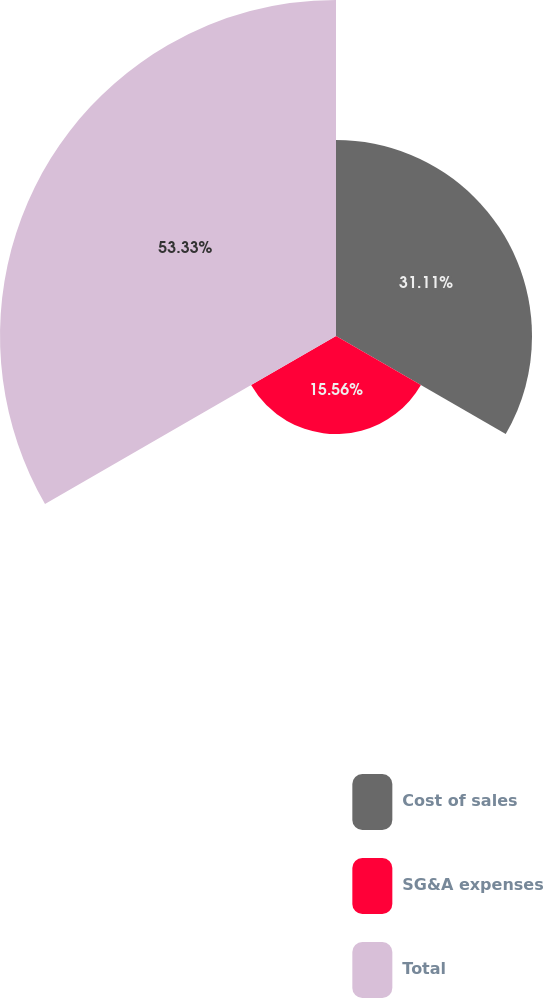<chart> <loc_0><loc_0><loc_500><loc_500><pie_chart><fcel>Cost of sales<fcel>SG&A expenses<fcel>Total<nl><fcel>31.11%<fcel>15.56%<fcel>53.33%<nl></chart> 